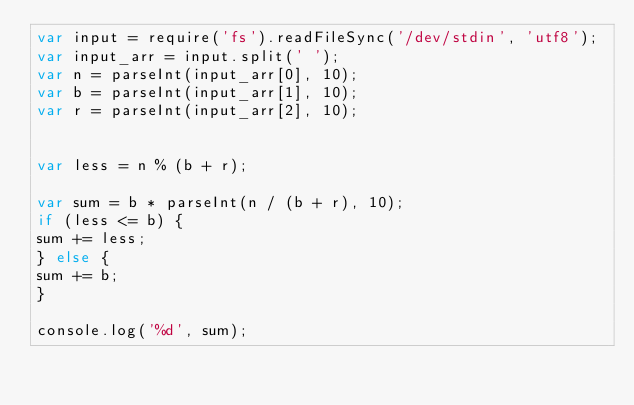<code> <loc_0><loc_0><loc_500><loc_500><_JavaScript_>var input = require('fs').readFileSync('/dev/stdin', 'utf8');
var input_arr = input.split(' ');
var n = parseInt(input_arr[0], 10);
var b = parseInt(input_arr[1], 10);
var r = parseInt(input_arr[2], 10);


var less = n % (b + r);

var sum = b * parseInt(n / (b + r), 10);
if (less <= b) {
sum += less;
} else {
sum += b;
}

console.log('%d', sum);
</code> 